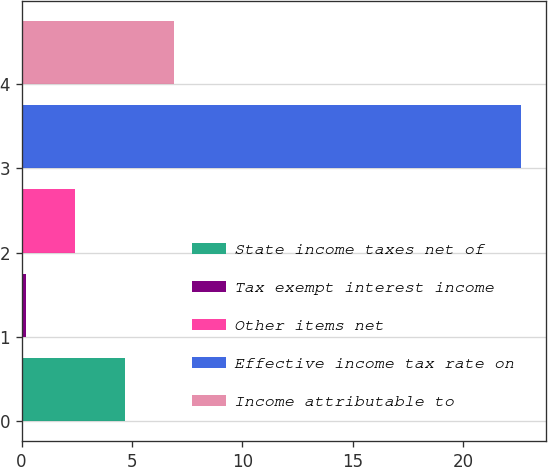<chart> <loc_0><loc_0><loc_500><loc_500><bar_chart><fcel>State income taxes net of<fcel>Tax exempt interest income<fcel>Other items net<fcel>Effective income tax rate on<fcel>Income attributable to<nl><fcel>4.68<fcel>0.2<fcel>2.44<fcel>22.6<fcel>6.92<nl></chart> 